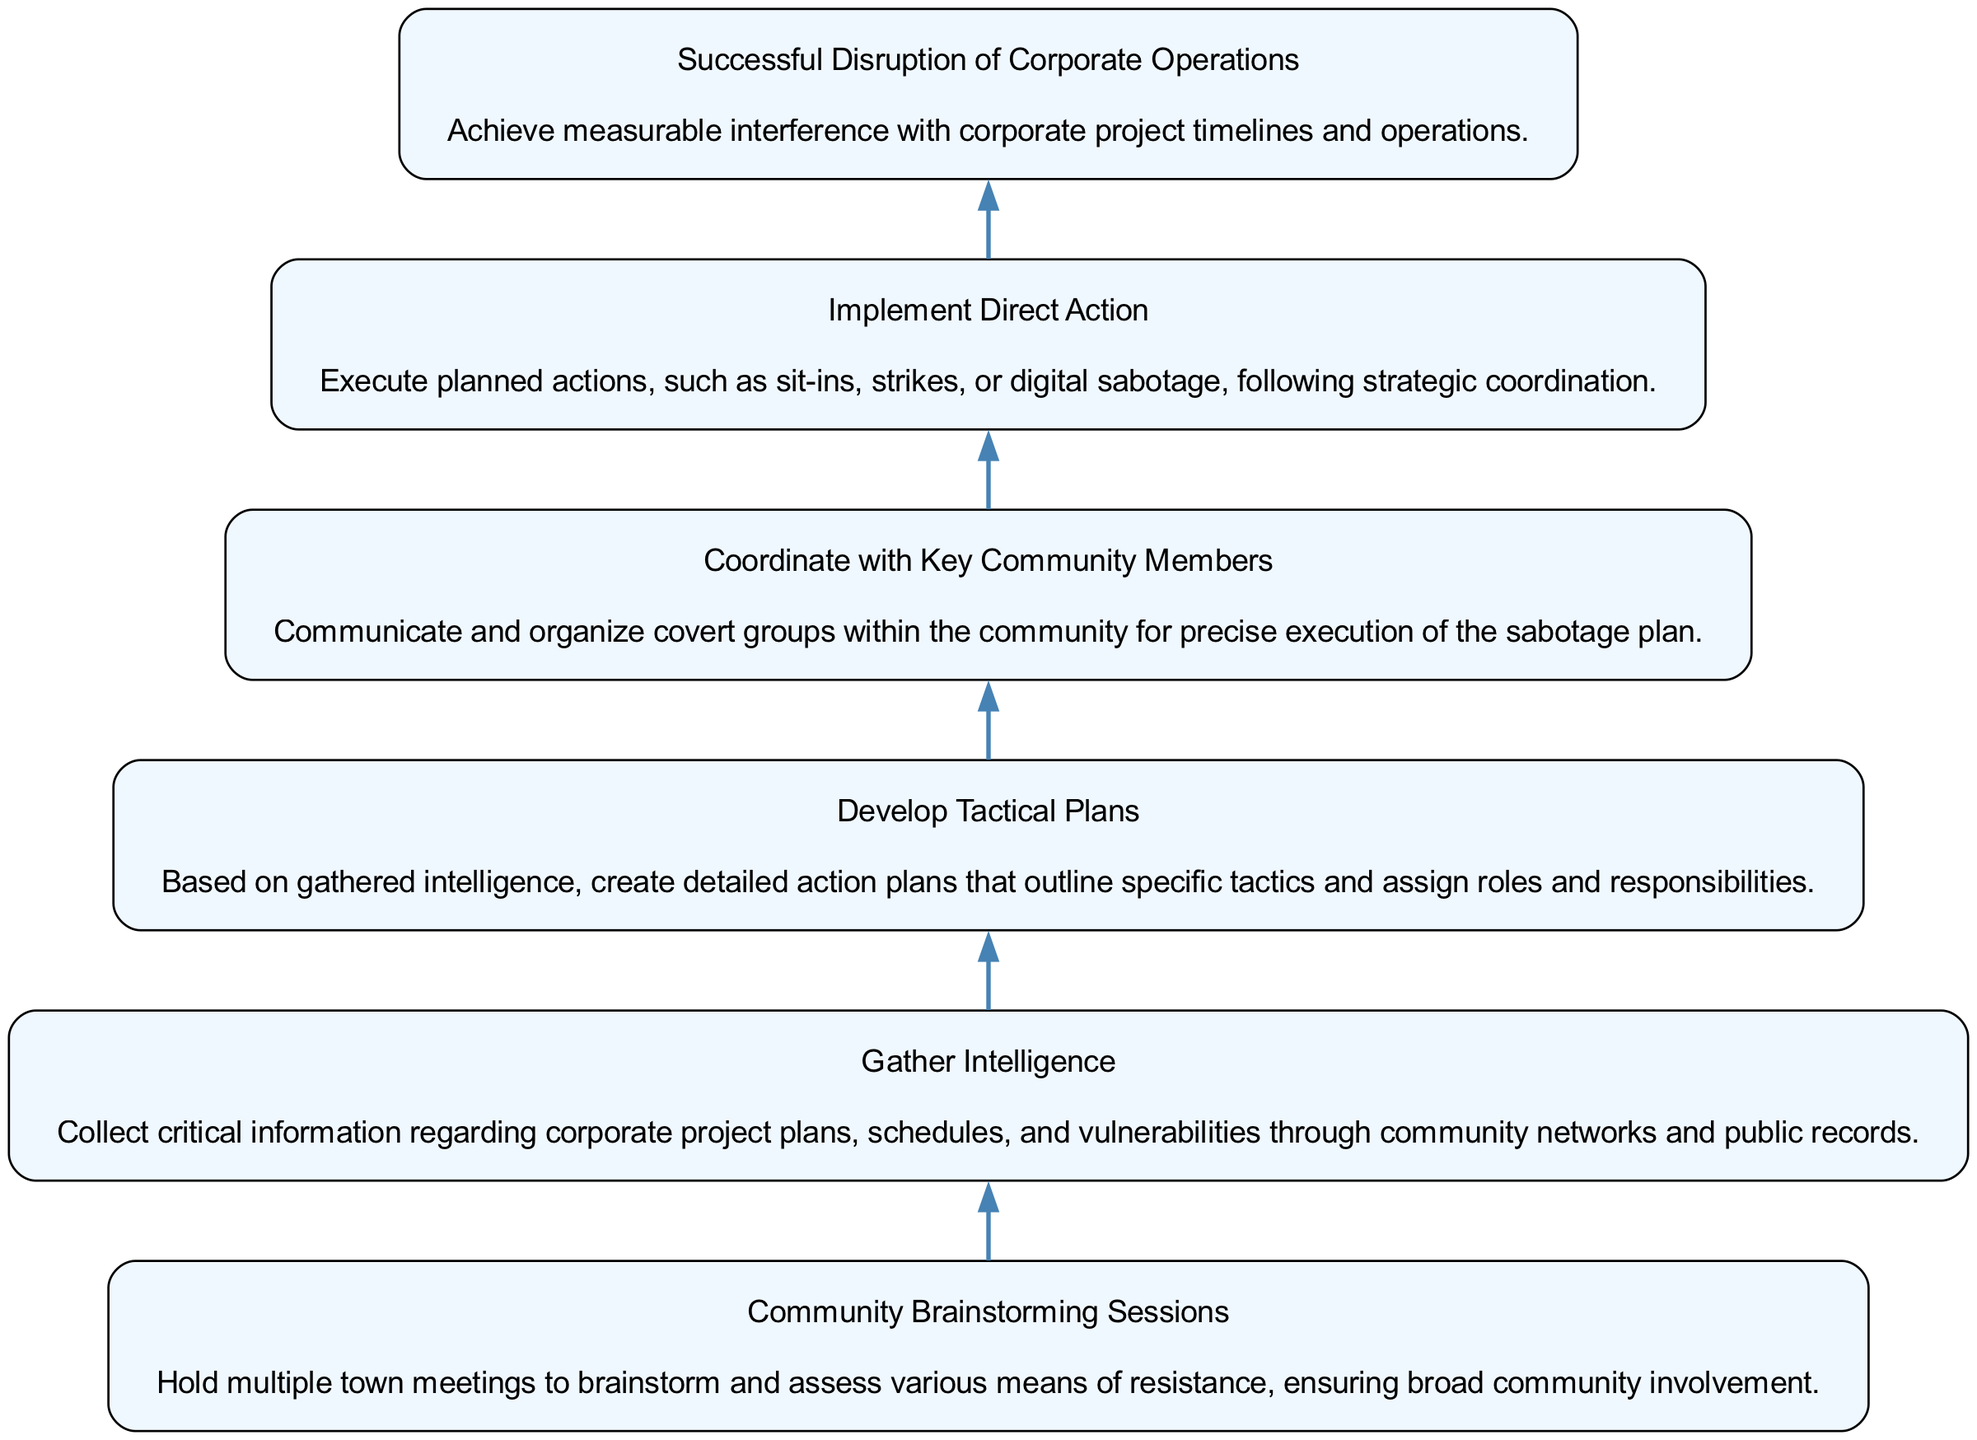What is the top node of the flowchart? The top node of the flowchart represents the final goal of the progression, which is identified as "Successful Disruption of Corporate Operations."
Answer: Successful Disruption of Corporate Operations How many nodes are in the flowchart? By counting each distinct step from the bottom to the top, we identify that there are a total of six nodes in the flowchart.
Answer: 6 What action follows "Develop Tactical Plans"? The action that directly follows "Develop Tactical Plans" in the flow is "Coordinate with Key Community Members," indicating the sequence of tasks.
Answer: Coordinate with Key Community Members What is the first step in the flowchart? The first step, at the bottom of the flowchart, is "Community Brainstorming Sessions," which indicates the starting point of the planning process.
Answer: Community Brainstorming Sessions Which node involves gathering information? The node that focuses specifically on gathering information is "Gather Intelligence," as it discusses the collection of vital data before further actions are taken.
Answer: Gather Intelligence What is required before implementing direct action? Before moving to "Implement Direct Action," it is necessary to complete the step "Develop Tactical Plans," which prepares the specific actions to take.
Answer: Develop Tactical Plans What is the last step to achieve disruption? The last step that describes achieving disruption is "Successful Disruption of Corporate Operations," reflecting the end goal of the plan.
Answer: Successful Disruption of Corporate Operations Which step emphasizes community involvement? The step that particularly emphasizes the importance of community participation in planning is "Community Brainstorming Sessions," as it involves broad engagement from the town.
Answer: Community Brainstorming Sessions What connects "Gather Intelligence" and "Develop Tactical Plans"? The connection between "Gather Intelligence" and "Develop Tactical Plans" is a direct progression—intelligence gathering informs the tactical plans that are to be developed next.
Answer: Develop Tactical Plans 